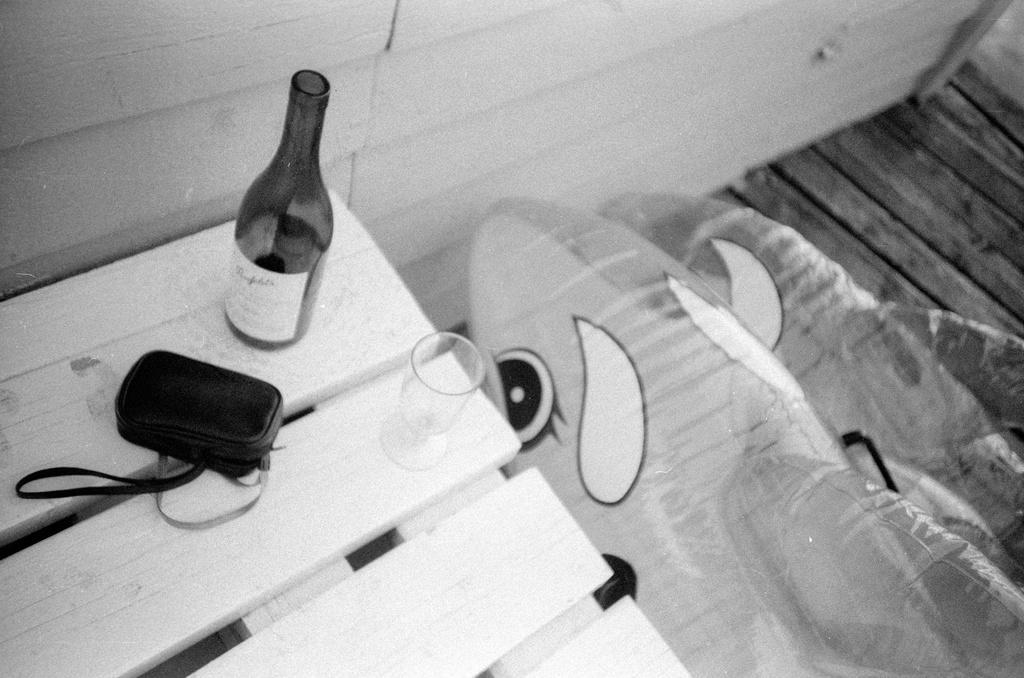What piece of furniture is present in the image? There is a table in the image. What is placed on the table? There is a wine bottle, a glass, and a purse on the table. What type of beverage might be associated with the wine bottle? The wine bottle suggests that there might be wine in the image. What is the color scheme of the image? The image is in black and white color. Can you see a skate being used on the table in the image? There is no skate present in the image, and it is not being used on the table. 